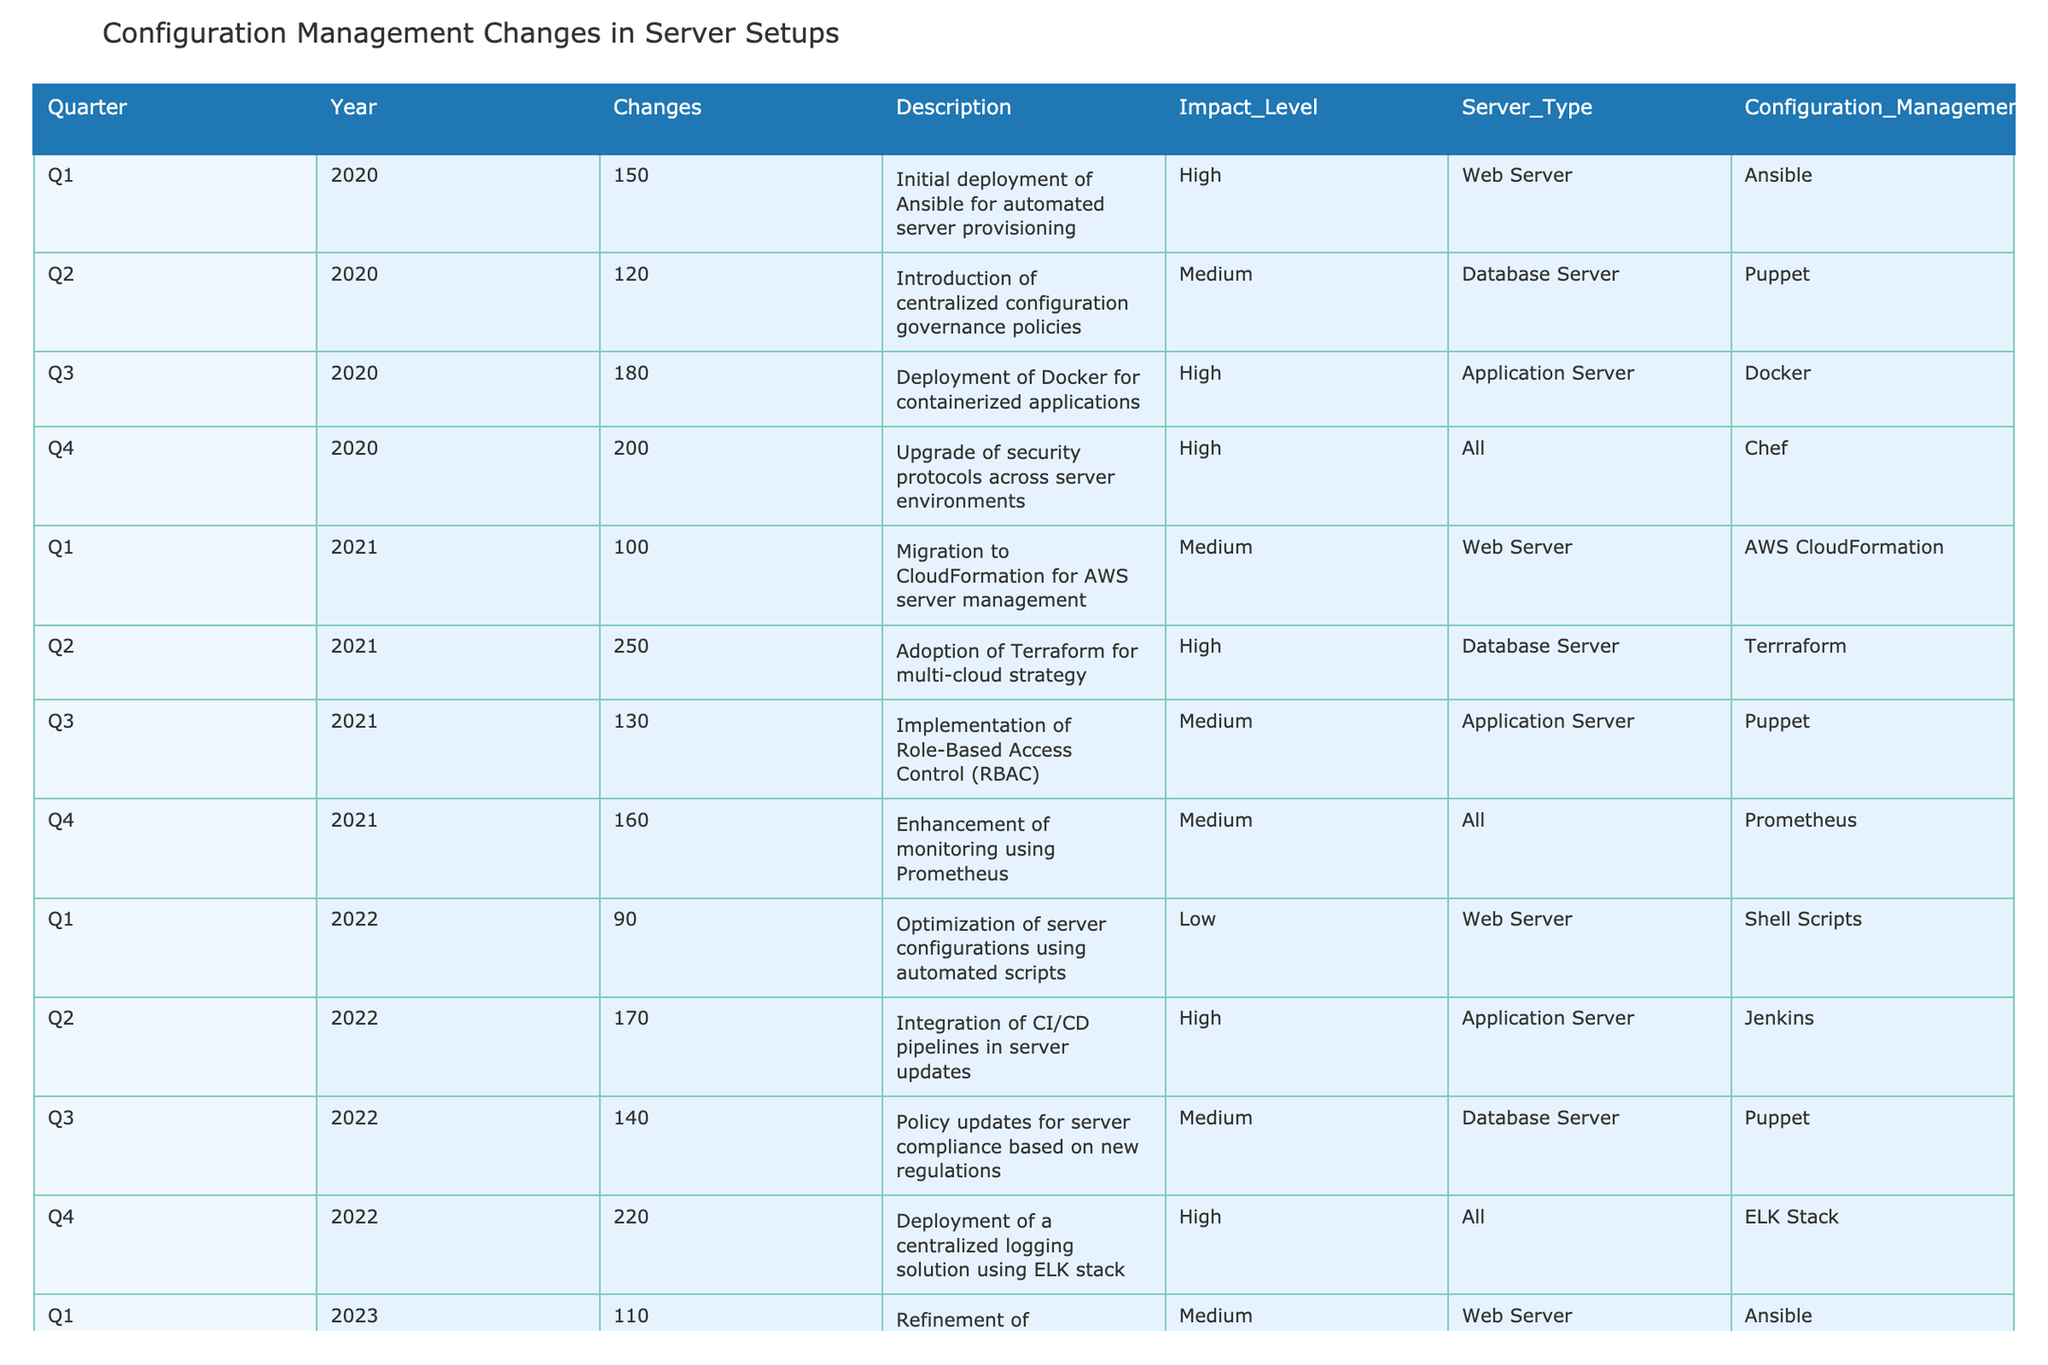What was the total number of changes made in Q4 2021? In Q4 2021, the table shows a total of 160 changes.
Answer: 160 Which year had the highest number of total changes across all quarters? By summing the values of changes for each year, 2022 has 620 changes, while 2023 has 690 changes, and 2021 has 640 changes. Therefore, 2023 has the highest total number of changes.
Answer: 2023 Was there a deployment of a centralized logging solution in 2022? Yes, in Q4 2022, the table indicates the deployment of a centralized logging solution using the ELK stack.
Answer: Yes What is the average impact level for the changes in 2020? The impact levels are categorized as High, Medium, and Low, which can be assigned numerical values of 3, 2, and 1, respectively. After converting the impact levels for each quarter (Q1=3, Q2=2, Q3=3, Q4=3), the average impact level is (3+2+3+3)/4 = 2.75, which is approximately 2.8.
Answer: 2.8 Which server type had the most frequent updates according to the table? By analyzing the server types, Web Server, Database Server, Application Server, and All are listed. The frequency of updates is: Web Server - 5, Database Server - 5, Application Server - 5, and All - 4 events. West Web Server, Database Server, and Application Server had the same number of updates at 5 each.
Answer: Web Server, Database Server, Application Server (all equal) What configuration management tool was used most frequently in Q1 across different years? Examining Q1 across multiple years: in 2020, the tool used was Ansible, in 2021 it was AWS CloudFormation, in 2022 it was Shell Scripts, and in 2023 it was again Ansible. Since Ansible is the only tool used twice in Q1, it is the most frequent tool for this period.
Answer: Ansible Did the number of configuration changes increase from Q1 2023 to Q2 2023? Yes, the number of changes in Q1 2023 was 110 and in Q2 2023 it was 160, indicating an increase of 50 changes.
Answer: Yes What was the change trend for application servers from 2020 to 2023? The changes for Application Servers are 180 in Q3 2020, 130 in Q3 2021, 170 in Q2 2022, and 160 in Q2 2023. Observing this trend shows a peak in 2020, a decline in 2021, then an increase in 2022 followed by a slight drop in 2023. Overall, there is variability but no steady upward or downward trend when considering the total periods analyzed.
Answer: Variable, not a steady trend 